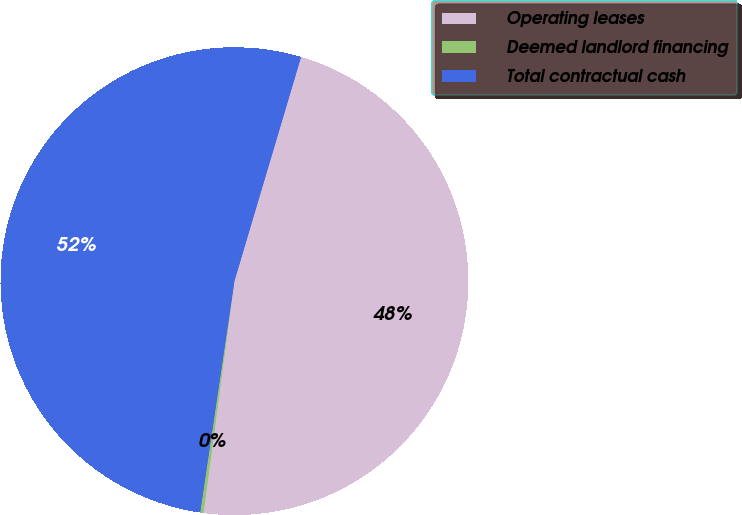Convert chart. <chart><loc_0><loc_0><loc_500><loc_500><pie_chart><fcel>Operating leases<fcel>Deemed landlord financing<fcel>Total contractual cash<nl><fcel>47.51%<fcel>0.23%<fcel>52.26%<nl></chart> 